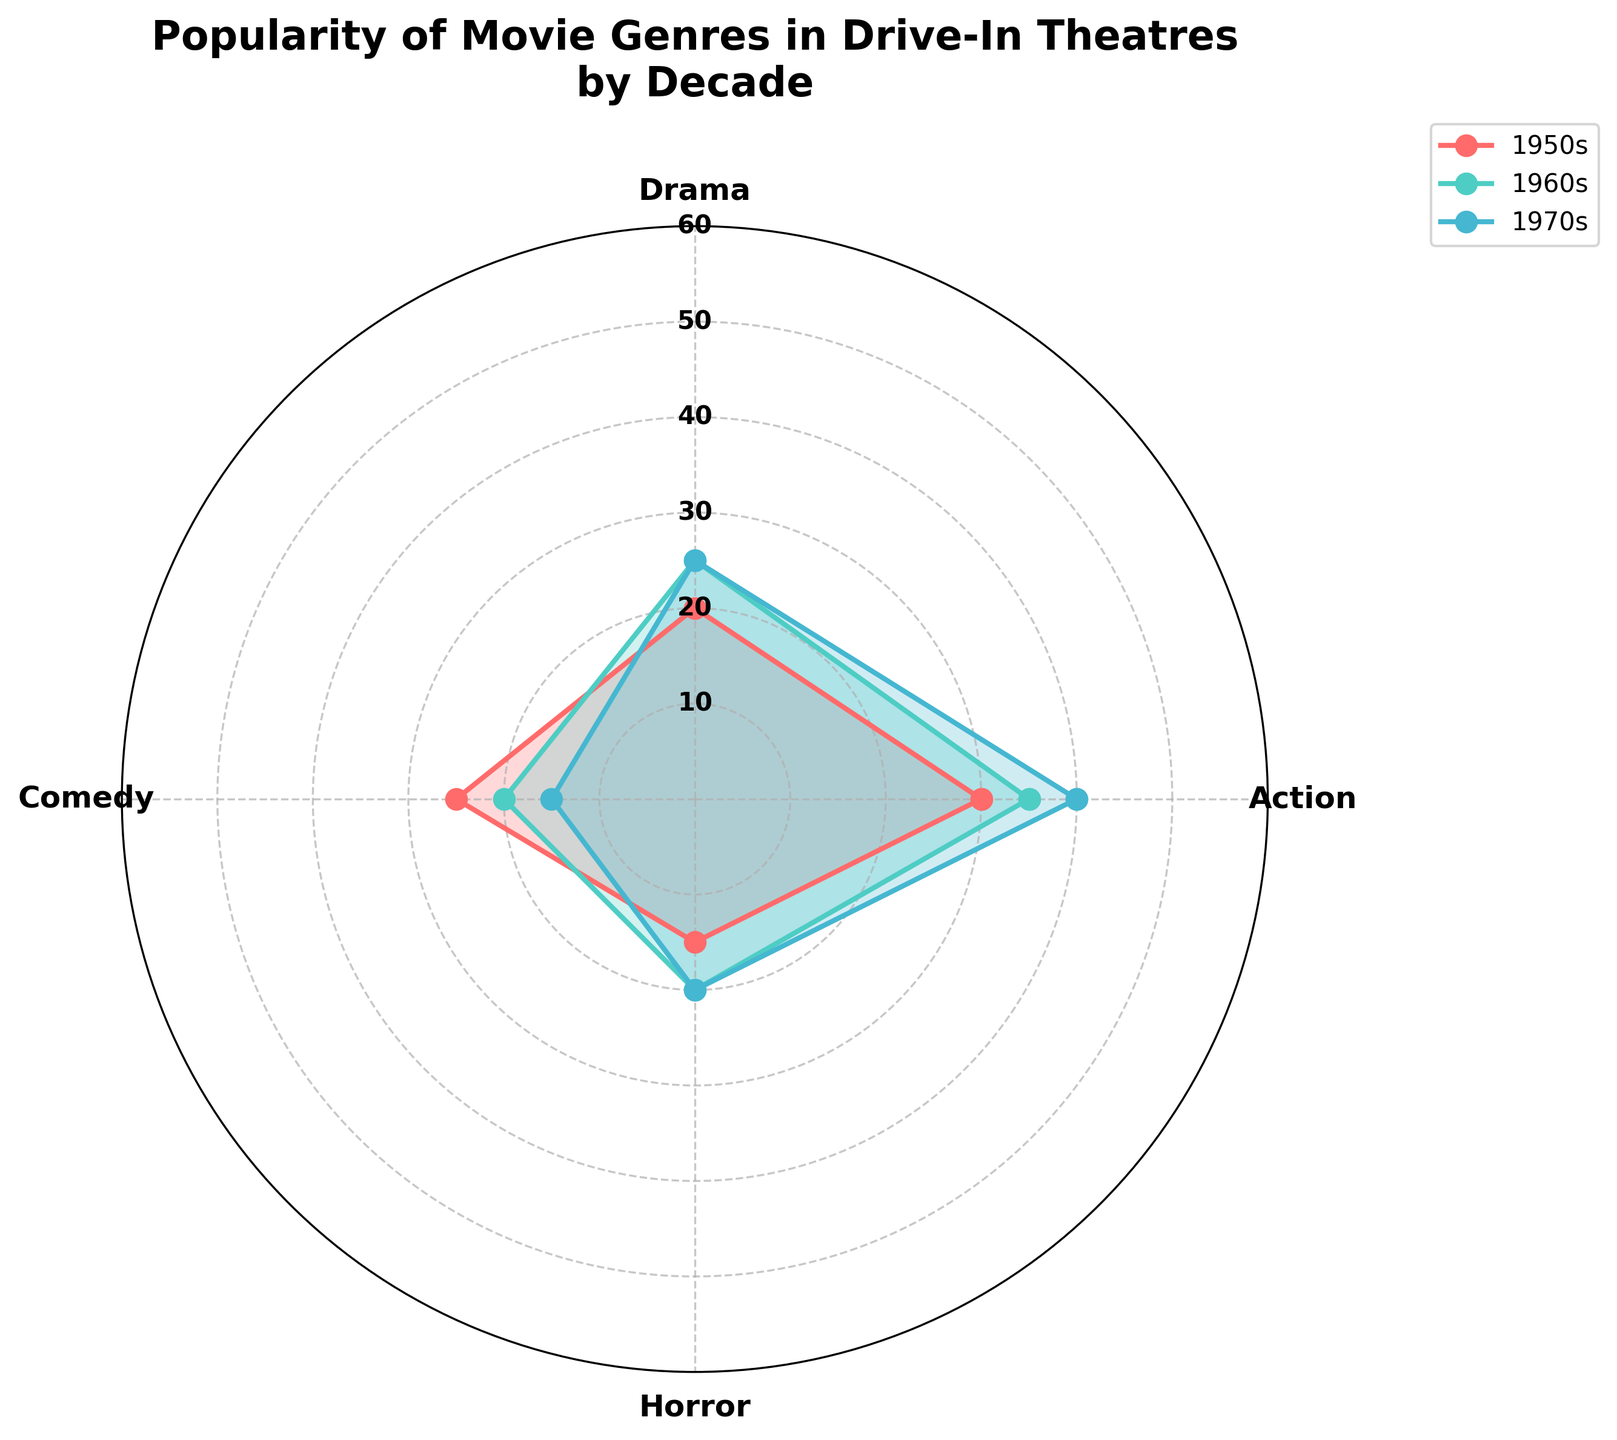Which decade has the highest popularity for Action movies? By examining the radar chart, the line representing the 1990s reaches the highest point in the Action genre, indicating its maximum popularity in that decade.
Answer: 1990s Which genre was least popular in the 1980s? The 1980s line on the radar chart shows the lowest value in the Horror genre, as it reaches the smallest radial distance in that section.
Answer: Horror How does the popularity of Drama movies in the 1950s compare to that in the 1960s? By comparing the corresponding points on the radar chart for the Drama genre, the 1960s line is farther from the center than the 1950s line, indicating higher popularity in the 1960s.
Answer: Higher in the 1960s What is the average popularity of Comedy movies in the plotted decades? The Comedy values for the 1950s, 1960s, and 1970s are 25, 20, and 15 respectively. The average is calculated as (25 + 20 + 15) / 3.
Answer: 20 Which decade shows the most balanced popularity across all genres (Action, Drama, Comedy, Horror)? By observing the radar chart, the 1960s decade seems to have more evenly distributed values across all genres, without any extreme highs or lows.
Answer: 1960s Between which consecutive decades does Action movie popularity increase the most? By examining the changes in the radar chart, the jump between the 1980s and 1990s shows the most significant increase in the distance from the center for the Action genre.
Answer: Between 1980s and 1990s In the 1970s, which genre is equally popular as Horror? Observing the radar chart for the 1970s, both Comedy and Horror genres intersect at the same distance from the center.
Answer: Comedy How does Horror movie popularity change from the 1950s to the 1960s? By comparing the radar chart points for Horror between the 1950s and 1960s, the popularity increases, shown by the line extending further out in the 1960s.
Answer: It increases What’s the difference in Comedy movie popularity between the 1950s and 1970s? The chart shows Comedy at 25 in the 1950s and 15 in the 1970s. The difference is 25 - 15.
Answer: 10 Which genre sees a consistent decline in popularity over the plotted decades? Reviewing the radar chart, the Horror genre consistently shows a decrease in its radial length over the decades 1950s, 1960s, and 1970s.
Answer: Horror 